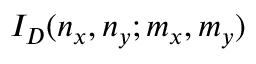<formula> <loc_0><loc_0><loc_500><loc_500>I _ { D } ( n _ { x } , n _ { y } ; m _ { x } , m _ { y } )</formula> 